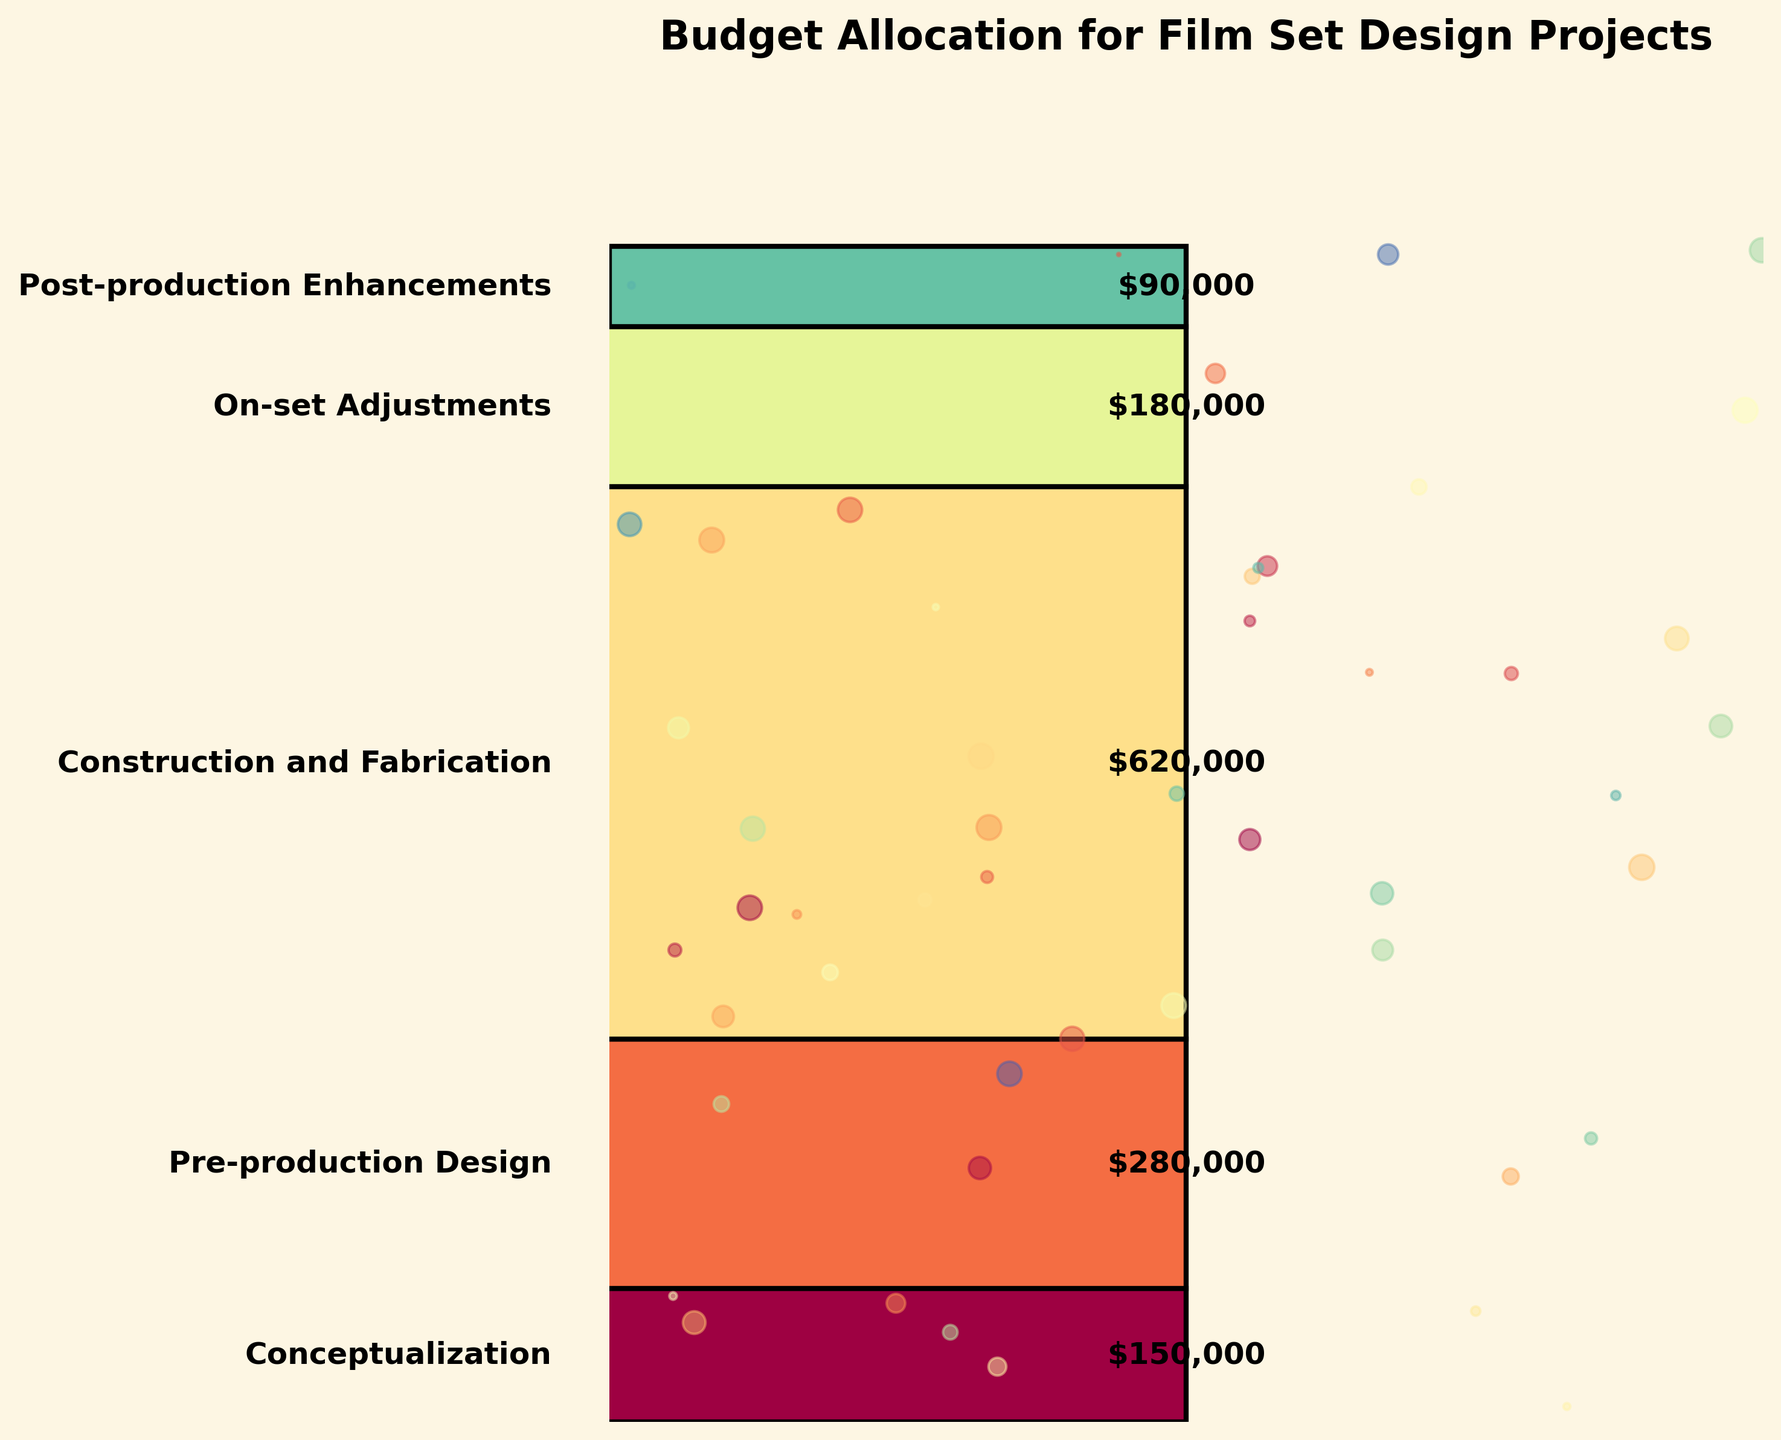What is the title of this chart? The title of the chart is usually placed at the top and it describes the overall content. In this chart, the title indicates what the chart is about.
Answer: "Budget Allocation for Film Set Design Projects" Which stage has the highest budget allocation? By looking at the chart, the widest part at the bottom represents the stage with the highest budget. The stage with the highest allocated budget can be found by identifying this part of the funnel.
Answer: "Construction and Fabrication" How much budget is allocated for On-set Adjustments? Each stage's budget allocation is labeled on the chart. Find the value near the middle of the chart for "On-set Adjustments".
Answer: "$180,000" What is the total budget allocated for the Pre-production Design and Construction and Fabrication stages? Add the budget values for the Pre-production Design and Construction and Fabrication stages. These are found on the chart labeled with each stage.
Answer: "$280,000 + $620,000 = $900,000" Which stage has the smallest budget allocation? The smallest part of the funnel, likely at the top, indicates the stage with the smallest budget allocation. Identify the stage associated with this narrowest section.
Answer: "Post-production Enhancements" Which stages have more than $200,000 budget allocation? From the chart, any stage bar with a value label greater than $200,000 will qualify. Identify these stages by reading the budget labels.
Answer: "Pre-production Design", "Construction and Fabrication", "On-set Adjustments" What is the difference in budget allocation between Conceptualization and On-set Adjustments? Subtract the budget allocation of Conceptualization from the budget allocation of On-set Adjustments, which are both labeled on the chart.
Answer: "$180,000 - $150,000 = $30,000" What percentage of the total budget is allocated for the Construction and Fabrication stage? First, sum up all the budget allocations. Next, divide the budget for Construction and Fabrication by the total budget, and multiply by 100 to get the percentage.
Answer: "$1,320,000 total, $620,000 for Construction and Fabrication. ($620,000 / $1,320,000) * 100 = 46.97%" Compare the budget allocation of Pre-production Design to Post-production Enhancements. Which is larger and by how much? Compare the budget allocations of these stages directly from the chart. Subtract the smaller value from the larger one to find the difference.
Answer: "Pre-production Design is larger by $280,000 - $90,000 = $190,000" If the budget for On-set Adjustments increased by 10%, what would be the new budget for this stage? Calculate 10% of On-set Adjustments' budget and add it to the original value. Refer to the chart for the initial budget.
Answer: "10% of $180,000 = $18,000, $180,000 + $18,000 = $198,000" 